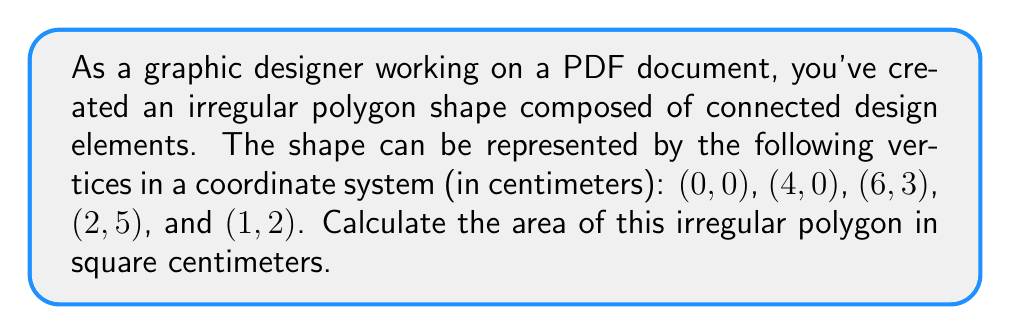Solve this math problem. To find the area of an irregular polygon, we can use the Shoelace formula (also known as the surveyor's formula). This method involves calculating the determinants of adjacent coordinates.

Let's follow these steps:

1) First, let's list our vertices in order:
   $(x_1, y_1) = (0, 0)$
   $(x_2, y_2) = (4, 0)$
   $(x_3, y_3) = (6, 3)$
   $(x_4, y_4) = (2, 5)$
   $(x_5, y_5) = (1, 2)$

2) The Shoelace formula is:

   $$A = \frac{1}{2}|(x_1y_2 + x_2y_3 + x_3y_4 + x_4y_5 + x_5y_1) - (y_1x_2 + y_2x_3 + y_3x_4 + y_4x_5 + y_5x_1)|$$

3) Let's substitute our values:

   $$A = \frac{1}{2}|(0 \cdot 0 + 4 \cdot 3 + 6 \cdot 5 + 2 \cdot 2 + 1 \cdot 0) - (0 \cdot 4 + 0 \cdot 6 + 3 \cdot 2 + 5 \cdot 1 + 2 \cdot 0)|$$

4) Simplify:

   $$A = \frac{1}{2}|(0 + 12 + 30 + 4 + 0) - (0 + 0 + 6 + 5 + 0)|$$
   $$A = \frac{1}{2}|46 - 11|$$
   $$A = \frac{1}{2}(35)$$
   $$A = 17.5$$

Therefore, the area of the irregular polygon is 17.5 square centimeters.

[asy]
unitsize(1cm);
draw((0,0)--(4,0)--(6,3)--(2,5)--(1,2)--cycle);
dot((0,0)); dot((4,0)); dot((6,3)); dot((2,5)); dot((1,2));
label("(0,0)", (0,0), SW);
label("(4,0)", (4,0), S);
label("(6,3)", (6,3), E);
label("(2,5)", (2,5), N);
label("(1,2)", (1,2), W);
[/asy]
Answer: The area of the irregular polygon is 17.5 square centimeters. 